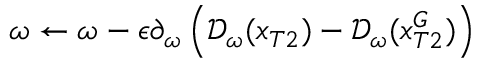Convert formula to latex. <formula><loc_0><loc_0><loc_500><loc_500>\omega \leftarrow \omega - \epsilon \partial _ { \omega } \left ( \mathcal { D } _ { \omega } ( x _ { T 2 } ) - \mathcal { D } _ { \omega } ( x _ { T 2 } ^ { G } ) \right )</formula> 